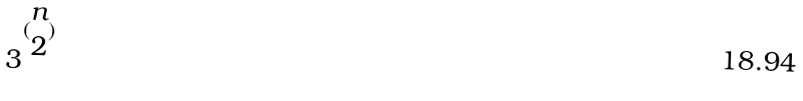<formula> <loc_0><loc_0><loc_500><loc_500>3 ^ { ( \begin{matrix} n \\ 2 \end{matrix} ) }</formula> 